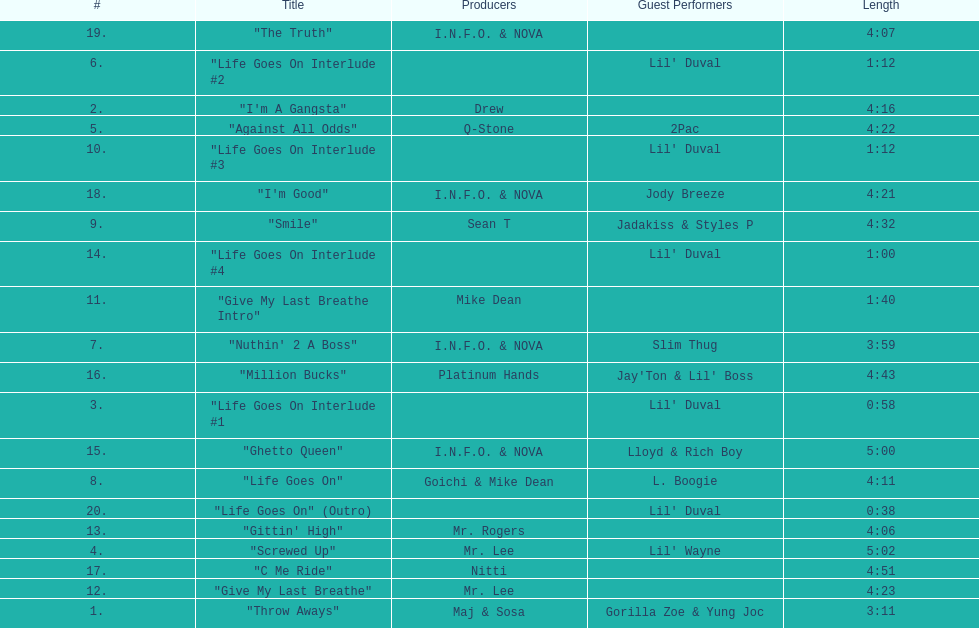How long is track number 11? 1:40. 